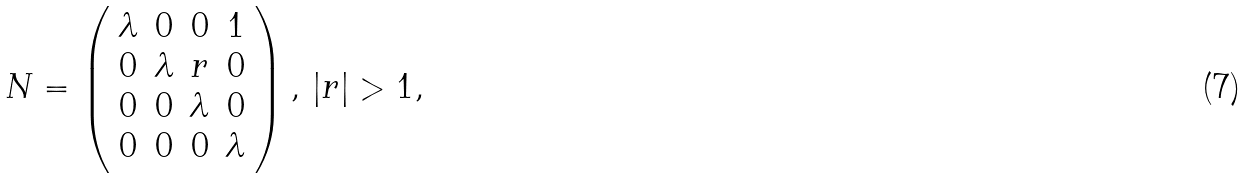<formula> <loc_0><loc_0><loc_500><loc_500>N = \left ( \begin{array} { c c c c } \lambda & 0 & 0 & 1 \\ 0 & \lambda & r & 0 \\ 0 & 0 & \lambda & 0 \\ 0 & 0 & 0 & \lambda \end{array} \right ) , \, | r | > 1 ,</formula> 